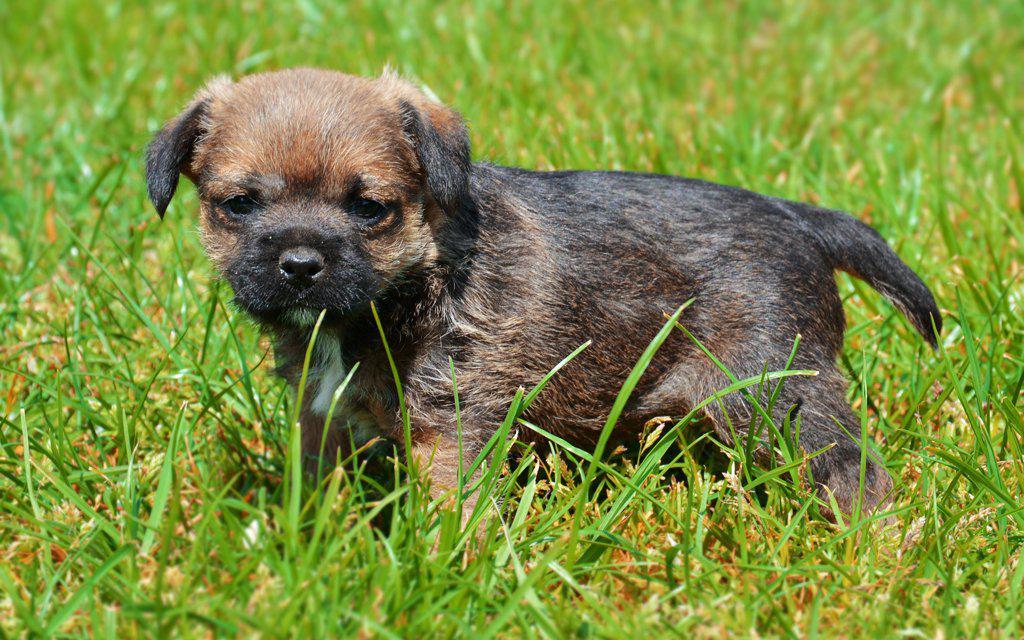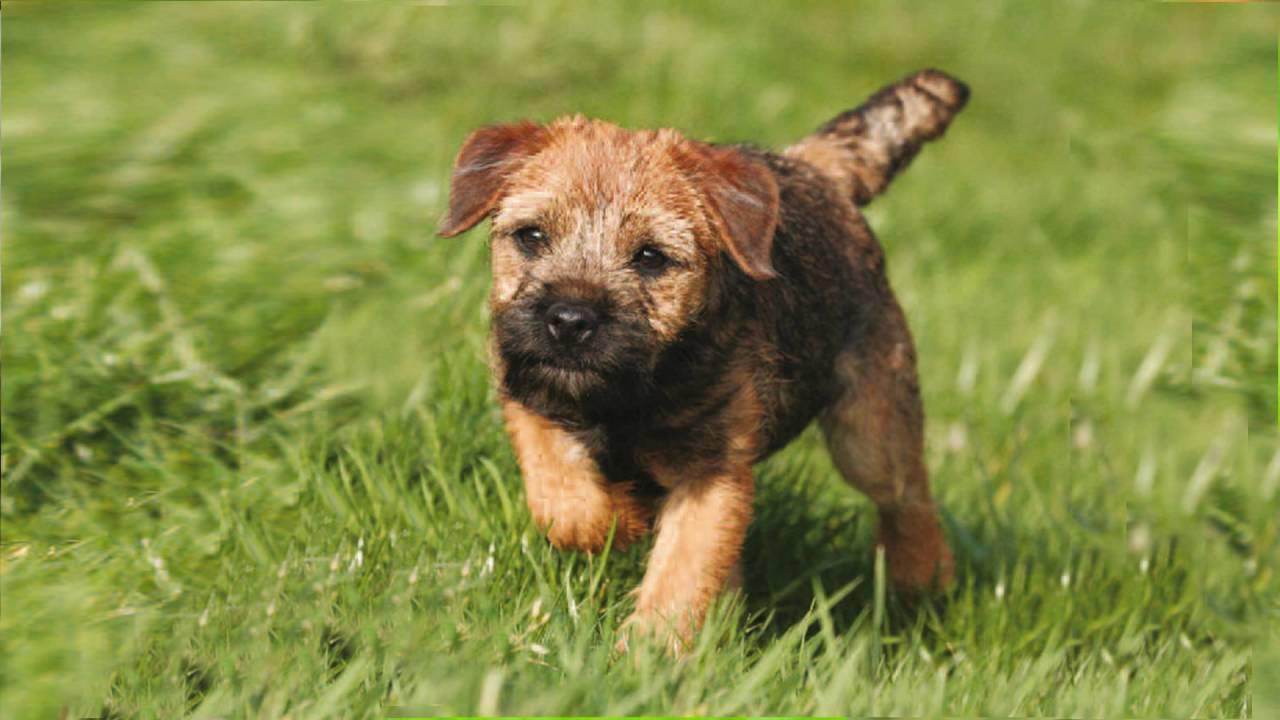The first image is the image on the left, the second image is the image on the right. For the images shown, is this caption "At least one image shows a small dog standing on green grass." true? Answer yes or no. Yes. The first image is the image on the left, the second image is the image on the right. Analyze the images presented: Is the assertion "At least one dog is standing on grass." valid? Answer yes or no. Yes. The first image is the image on the left, the second image is the image on the right. For the images displayed, is the sentence "A dog is standing in the grass with the paw on the left raised." factually correct? Answer yes or no. Yes. 